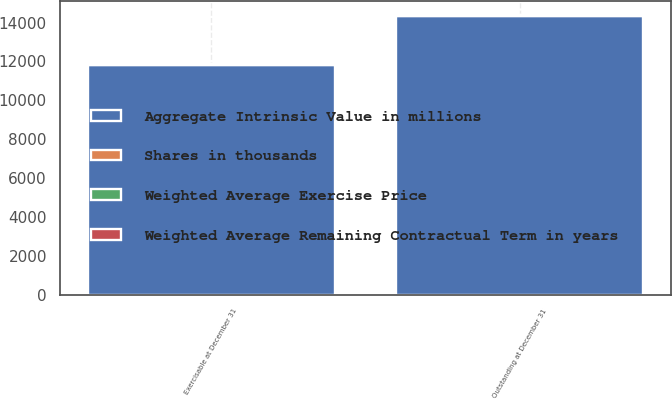Convert chart. <chart><loc_0><loc_0><loc_500><loc_500><stacked_bar_chart><ecel><fcel>Outstanding at December 31<fcel>Exercisable at December 31<nl><fcel>Aggregate Intrinsic Value in millions<fcel>14316<fcel>11800<nl><fcel>Shares in thousands<fcel>51.86<fcel>47.96<nl><fcel>Weighted Average Remaining Contractual Term in years<fcel>4.62<fcel>3.88<nl><fcel>Weighted Average Exercise Price<fcel>1<fcel>1<nl></chart> 